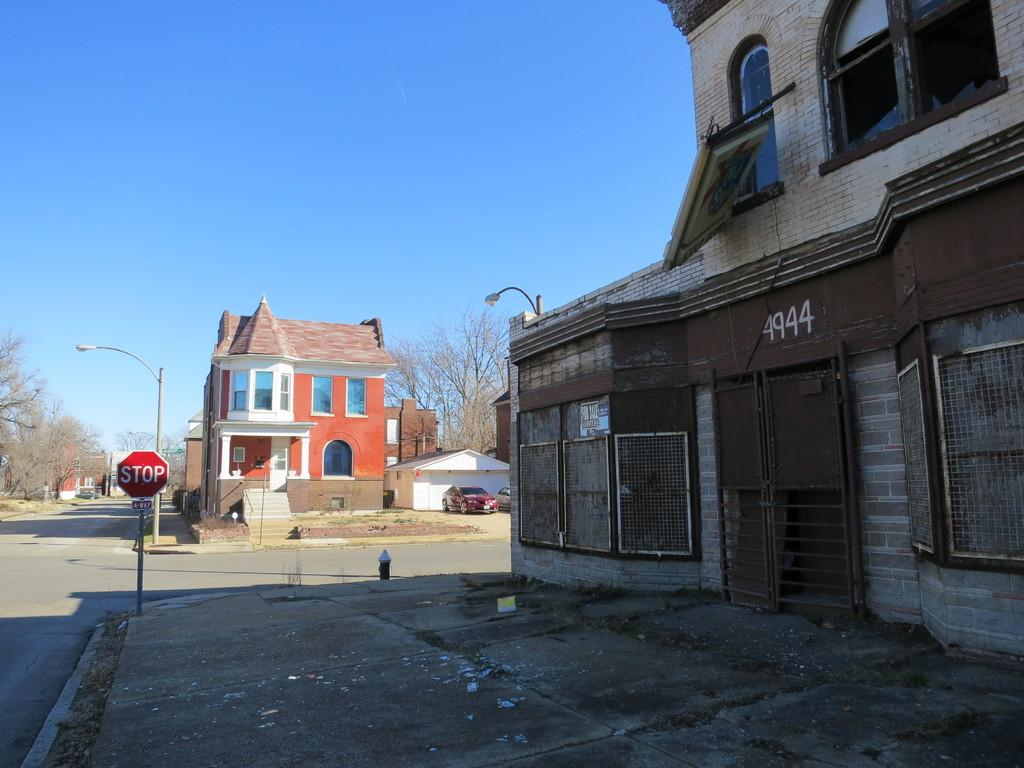What is the main feature of the image? There is a road in the image. What is located beside the road? There is a sign board beside the road. What can be seen illuminating the road at night? Streetlights are present in the image. What type of structures are visible in the image? There are buildings in the image. What is moving along the road? Vehicles are visible in the image. What can be seen in the background of the image? There are trees and the sky visible in the background of the image. What type of vegetable is being cooked on the stove in the image? There is no stove or vegetable present in the image. What shape is the circle in the image? There is no circle present in the image. 